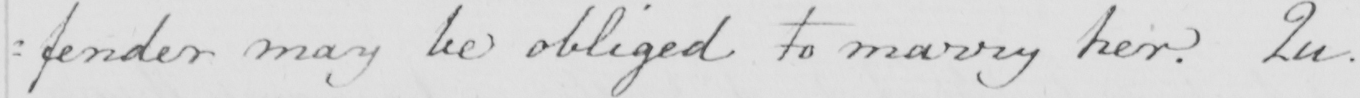Can you tell me what this handwritten text says? : fender may be obliged to marry her . Qu . 